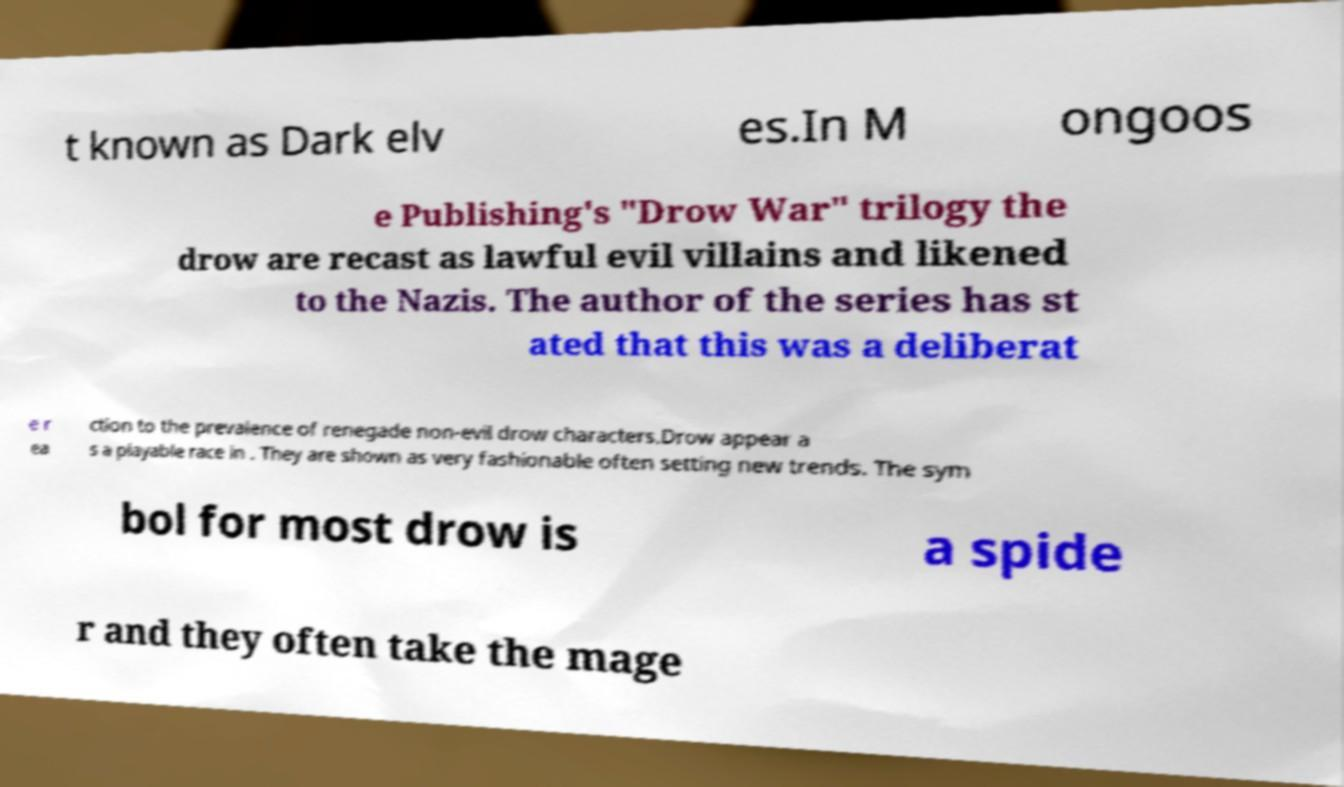Please read and relay the text visible in this image. What does it say? t known as Dark elv es.In M ongoos e Publishing's "Drow War" trilogy the drow are recast as lawful evil villains and likened to the Nazis. The author of the series has st ated that this was a deliberat e r ea ction to the prevalence of renegade non-evil drow characters.Drow appear a s a playable race in . They are shown as very fashionable often setting new trends. The sym bol for most drow is a spide r and they often take the mage 